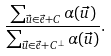<formula> <loc_0><loc_0><loc_500><loc_500>\frac { \sum _ { \vec { u } \in \vec { e } + C } \alpha ( \vec { u } ) } { \sum _ { \vec { u } \in \vec { e } + C ^ { \perp } } \alpha ( \vec { u } ) } .</formula> 